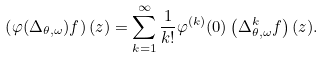<formula> <loc_0><loc_0><loc_500><loc_500>\left ( \varphi ( \Delta _ { \theta , \omega } ) f \right ) ( z ) = \sum _ { k = 1 } ^ { \infty } \frac { 1 } { k ! } \varphi ^ { ( k ) } ( 0 ) \left ( \Delta _ { \theta , \omega } ^ { k } f \right ) ( z ) .</formula> 